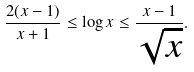Convert formula to latex. <formula><loc_0><loc_0><loc_500><loc_500>\frac { 2 ( x - 1 ) } { x + 1 } \leq \log x \leq \frac { x - 1 } { \sqrt { x } } .</formula> 